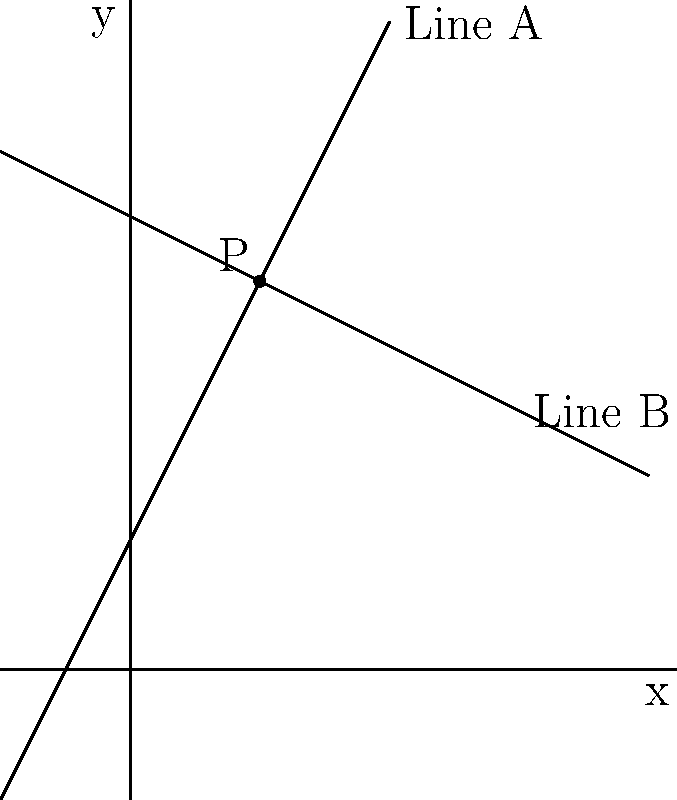In a stark noir cityscape reminiscent of Frank Miller's "Sin City", two shadowy figures cast intersecting silhouettes represented by lines A and B. Line A has a slope of 2, and both lines intersect at point P(1,3). If these lines are perpendicular, what is the equation of Line B in slope-intercept form? Let's approach this step-by-step:

1) We know that Line A has a slope of 2. Let's call this $m_A = 2$.

2) For perpendicular lines, the product of their slopes is -1. So if we call the slope of Line B $m_B$, we have:

   $m_A \cdot m_B = -1$

3) Substituting the known value:

   $2 \cdot m_B = -1$

4) Solving for $m_B$:

   $m_B = -\frac{1}{2}$

5) Now we have the slope of Line B. We also know a point on this line: P(1,3).

6) We can use the point-slope form of a line to find the equation:

   $y - y_1 = m(x - x_1)$
   $y - 3 = -\frac{1}{2}(x - 1)$

7) Expand this:

   $y - 3 = -\frac{1}{2}x + \frac{1}{2}$

8) Rearrange to slope-intercept form $(y = mx + b)$:

   $y = -\frac{1}{2}x + \frac{1}{2} + 3$
   $y = -\frac{1}{2}x + \frac{7}{2}$

Therefore, the equation of Line B in slope-intercept form is $y = -\frac{1}{2}x + \frac{7}{2}$.
Answer: $y = -\frac{1}{2}x + \frac{7}{2}$ 